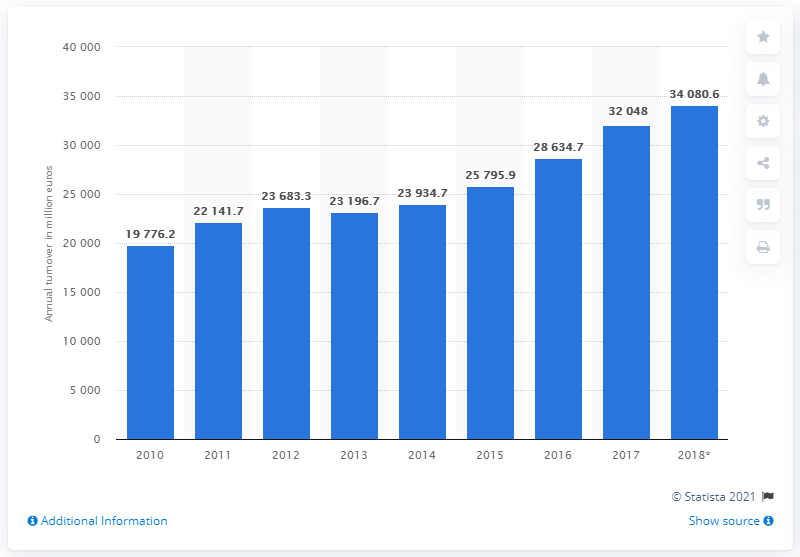Outline some significant characteristics in this image. In 2017, the turnover of the building construction industry in Sweden was 32,048. In 2017, the turnover of the building construction industry in Sweden was 34,080.6 million SEK. 